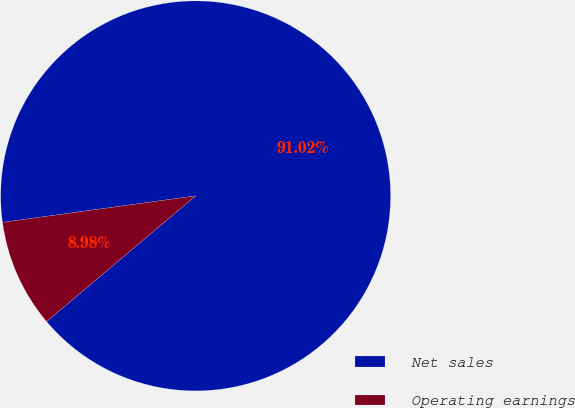<chart> <loc_0><loc_0><loc_500><loc_500><pie_chart><fcel>Net sales<fcel>Operating earnings<nl><fcel>91.02%<fcel>8.98%<nl></chart> 